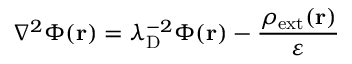<formula> <loc_0><loc_0><loc_500><loc_500>\nabla ^ { 2 } \Phi ( r ) = \lambda _ { D } ^ { - 2 } \Phi ( r ) - { \frac { \rho _ { e x t } ( r ) } { \varepsilon } }</formula> 